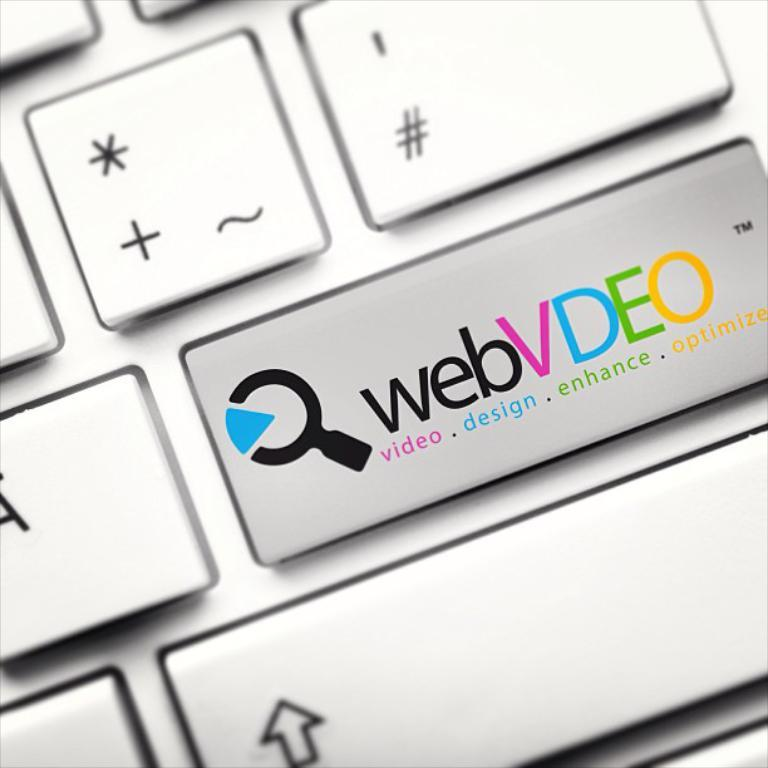<image>
Create a compact narrative representing the image presented. A laptop keyboard focused on the webvdeo button. 